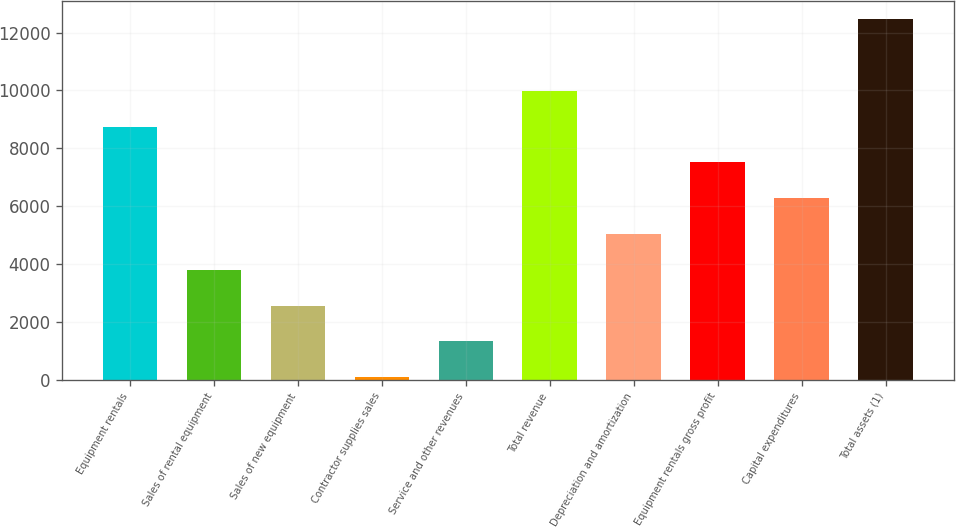Convert chart to OTSL. <chart><loc_0><loc_0><loc_500><loc_500><bar_chart><fcel>Equipment rentals<fcel>Sales of rental equipment<fcel>Sales of new equipment<fcel>Contractor supplies sales<fcel>Service and other revenues<fcel>Total revenue<fcel>Depreciation and amortization<fcel>Equipment rentals gross profit<fcel>Capital expenditures<fcel>Total assets (1)<nl><fcel>8752.4<fcel>3799.6<fcel>2561.4<fcel>85<fcel>1323.2<fcel>9990.6<fcel>5037.8<fcel>7514.2<fcel>6276<fcel>12467<nl></chart> 